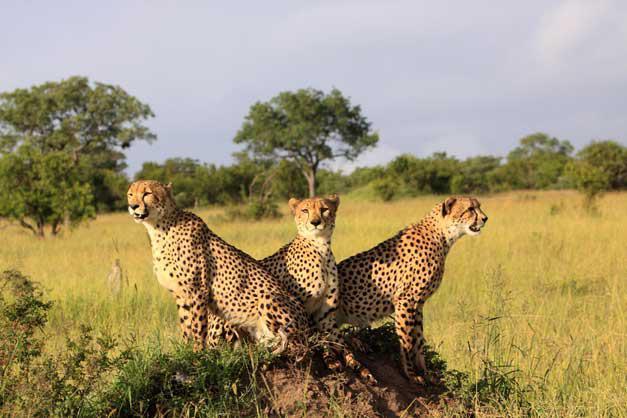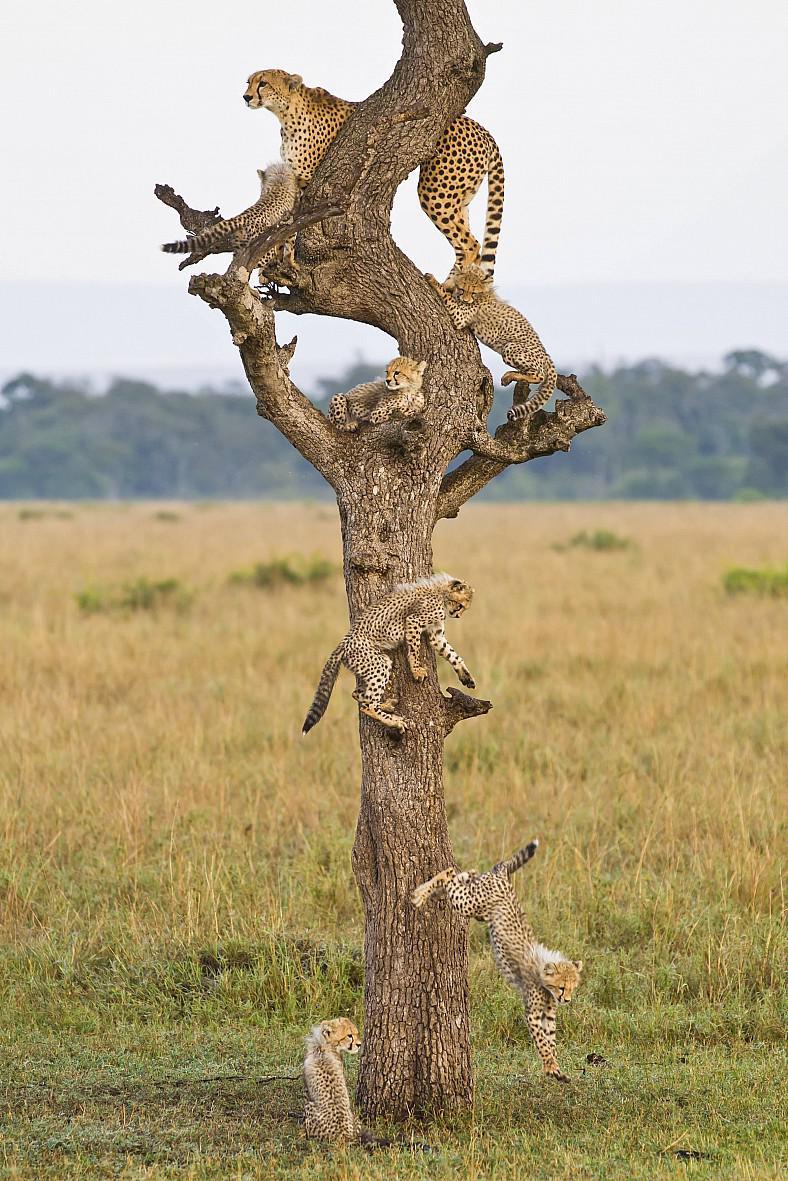The first image is the image on the left, the second image is the image on the right. Evaluate the accuracy of this statement regarding the images: "There is a cheetah with a dead caracal in one image, and two cheetahs in the other image.". Is it true? Answer yes or no. No. The first image is the image on the left, the second image is the image on the right. Examine the images to the left and right. Is the description "A cheetah is on its back in front of another cheetah who is above it in one image." accurate? Answer yes or no. No. 